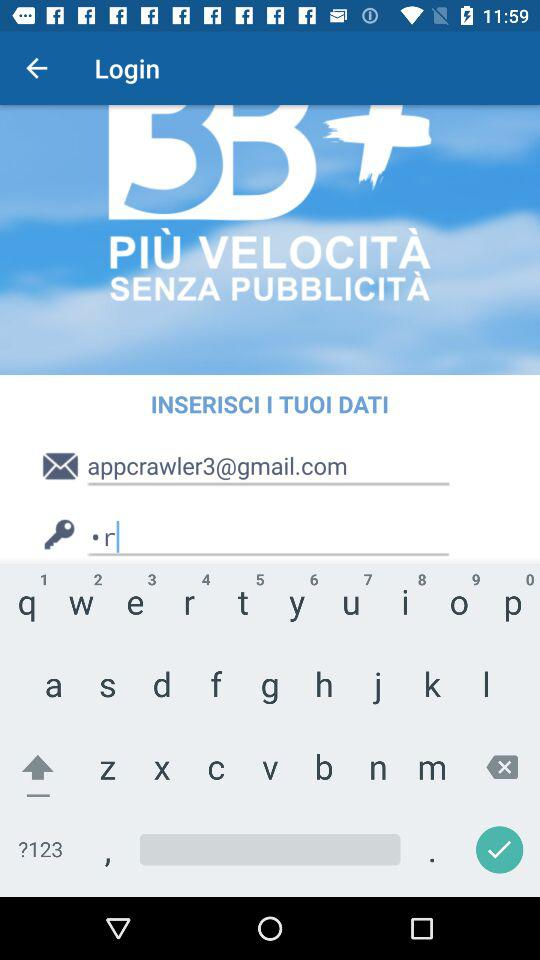How many weather forecast videos are there?
Answer the question using a single word or phrase. 3 